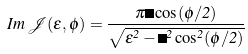<formula> <loc_0><loc_0><loc_500><loc_500>I m \, \mathcal { J } ( \epsilon , \phi ) = \frac { \pi \Delta \cos ( \phi / 2 ) } { \sqrt { \epsilon ^ { 2 } - \Delta ^ { 2 } \cos ^ { 2 } ( \phi / 2 ) } }</formula> 